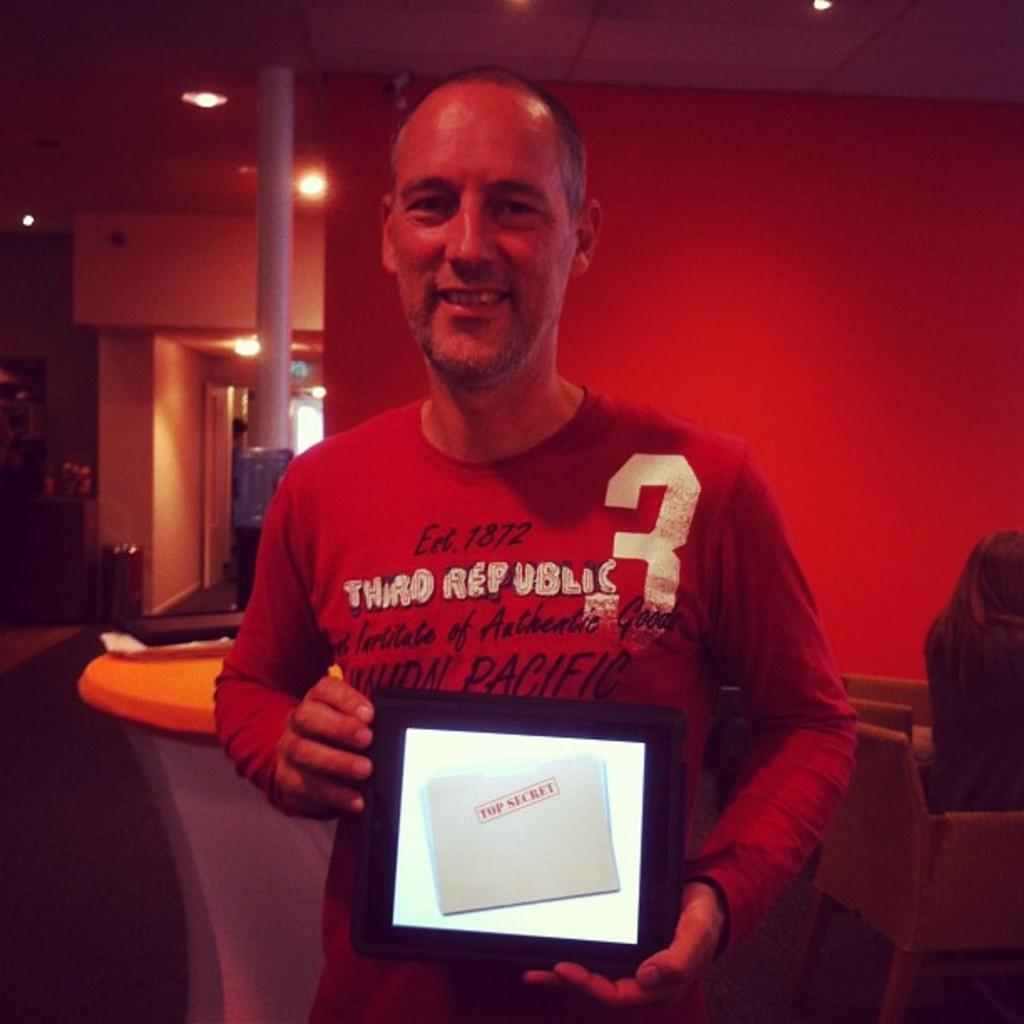How would you summarize this image in a sentence or two? There is a man with red t-shirt is standing and holding a tab in his hand. He is smiling. Behind him there is a table. To the right side corner there is a chair with a lady sitting on it. In the background there is a wall with orange color. And to the side of the there is a pillar. To the left side there is a table with some items on it. Beside the table there is a dustbin. 